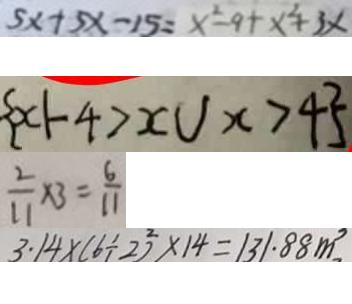Convert formula to latex. <formula><loc_0><loc_0><loc_500><loc_500>5 x + 5 x - 1 5 = x ^ { 2 } - 9 + x ^ { 2 } + 3 x 
 \{ x \vert - 4 > x \cup x > 4 \} 
 \frac { 2 } { 1 1 } \times 3 = \frac { 6 } { 1 1 } 
 3 . 1 4 \times ( 6 \div 2 ) ^ { 2 } \times 1 4 = 1 3 1 . 8 8 m ^ { 3 }</formula> 